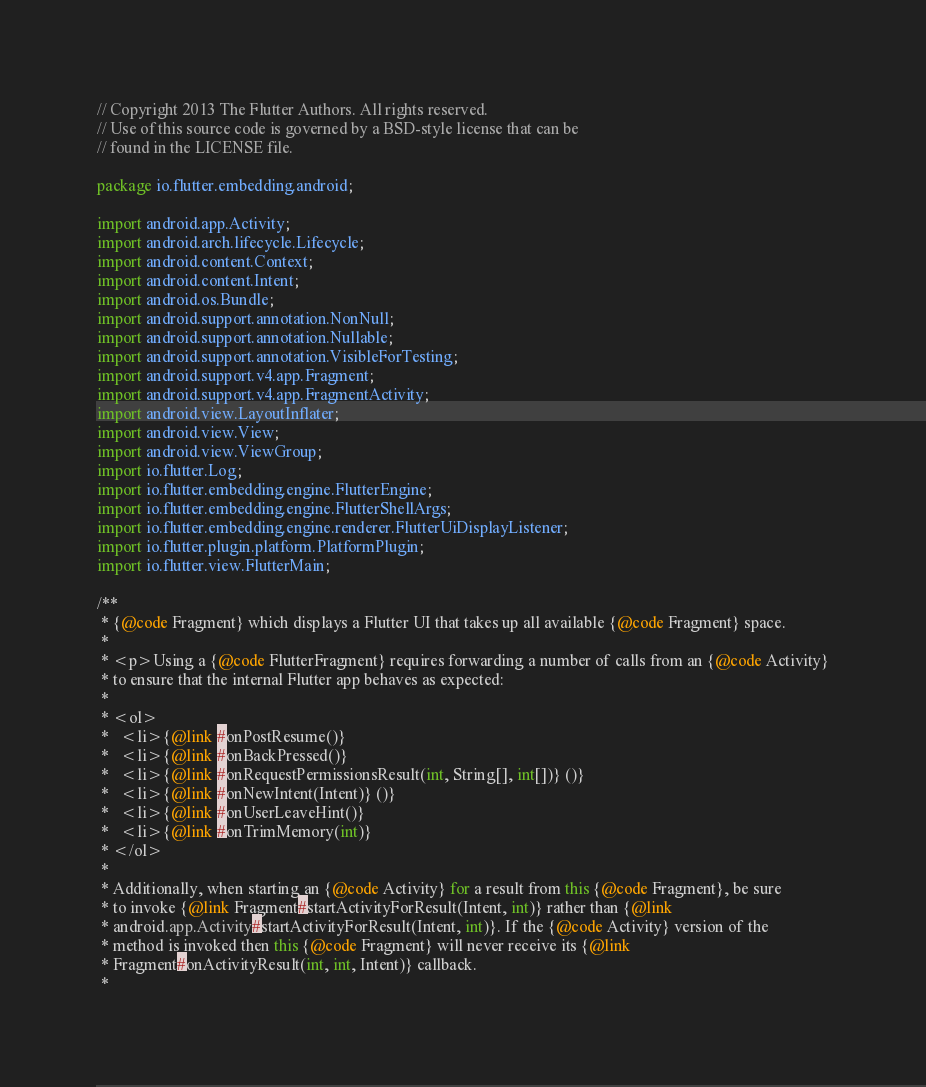<code> <loc_0><loc_0><loc_500><loc_500><_Java_>// Copyright 2013 The Flutter Authors. All rights reserved.
// Use of this source code is governed by a BSD-style license that can be
// found in the LICENSE file.

package io.flutter.embedding.android;

import android.app.Activity;
import android.arch.lifecycle.Lifecycle;
import android.content.Context;
import android.content.Intent;
import android.os.Bundle;
import android.support.annotation.NonNull;
import android.support.annotation.Nullable;
import android.support.annotation.VisibleForTesting;
import android.support.v4.app.Fragment;
import android.support.v4.app.FragmentActivity;
import android.view.LayoutInflater;
import android.view.View;
import android.view.ViewGroup;
import io.flutter.Log;
import io.flutter.embedding.engine.FlutterEngine;
import io.flutter.embedding.engine.FlutterShellArgs;
import io.flutter.embedding.engine.renderer.FlutterUiDisplayListener;
import io.flutter.plugin.platform.PlatformPlugin;
import io.flutter.view.FlutterMain;

/**
 * {@code Fragment} which displays a Flutter UI that takes up all available {@code Fragment} space.
 *
 * <p>Using a {@code FlutterFragment} requires forwarding a number of calls from an {@code Activity}
 * to ensure that the internal Flutter app behaves as expected:
 *
 * <ol>
 *   <li>{@link #onPostResume()}
 *   <li>{@link #onBackPressed()}
 *   <li>{@link #onRequestPermissionsResult(int, String[], int[])} ()}
 *   <li>{@link #onNewIntent(Intent)} ()}
 *   <li>{@link #onUserLeaveHint()}
 *   <li>{@link #onTrimMemory(int)}
 * </ol>
 *
 * Additionally, when starting an {@code Activity} for a result from this {@code Fragment}, be sure
 * to invoke {@link Fragment#startActivityForResult(Intent, int)} rather than {@link
 * android.app.Activity#startActivityForResult(Intent, int)}. If the {@code Activity} version of the
 * method is invoked then this {@code Fragment} will never receive its {@link
 * Fragment#onActivityResult(int, int, Intent)} callback.
 *</code> 